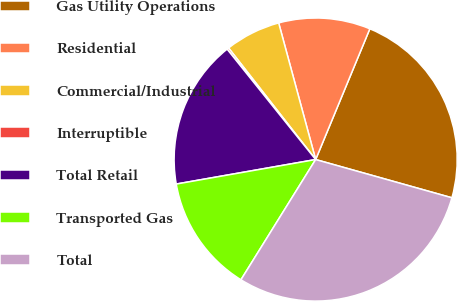<chart> <loc_0><loc_0><loc_500><loc_500><pie_chart><fcel>Gas Utility Operations<fcel>Residential<fcel>Commercial/Industrial<fcel>Interruptible<fcel>Total Retail<fcel>Transported Gas<fcel>Total<nl><fcel>23.1%<fcel>10.46%<fcel>6.34%<fcel>0.21%<fcel>17.01%<fcel>13.38%<fcel>29.49%<nl></chart> 